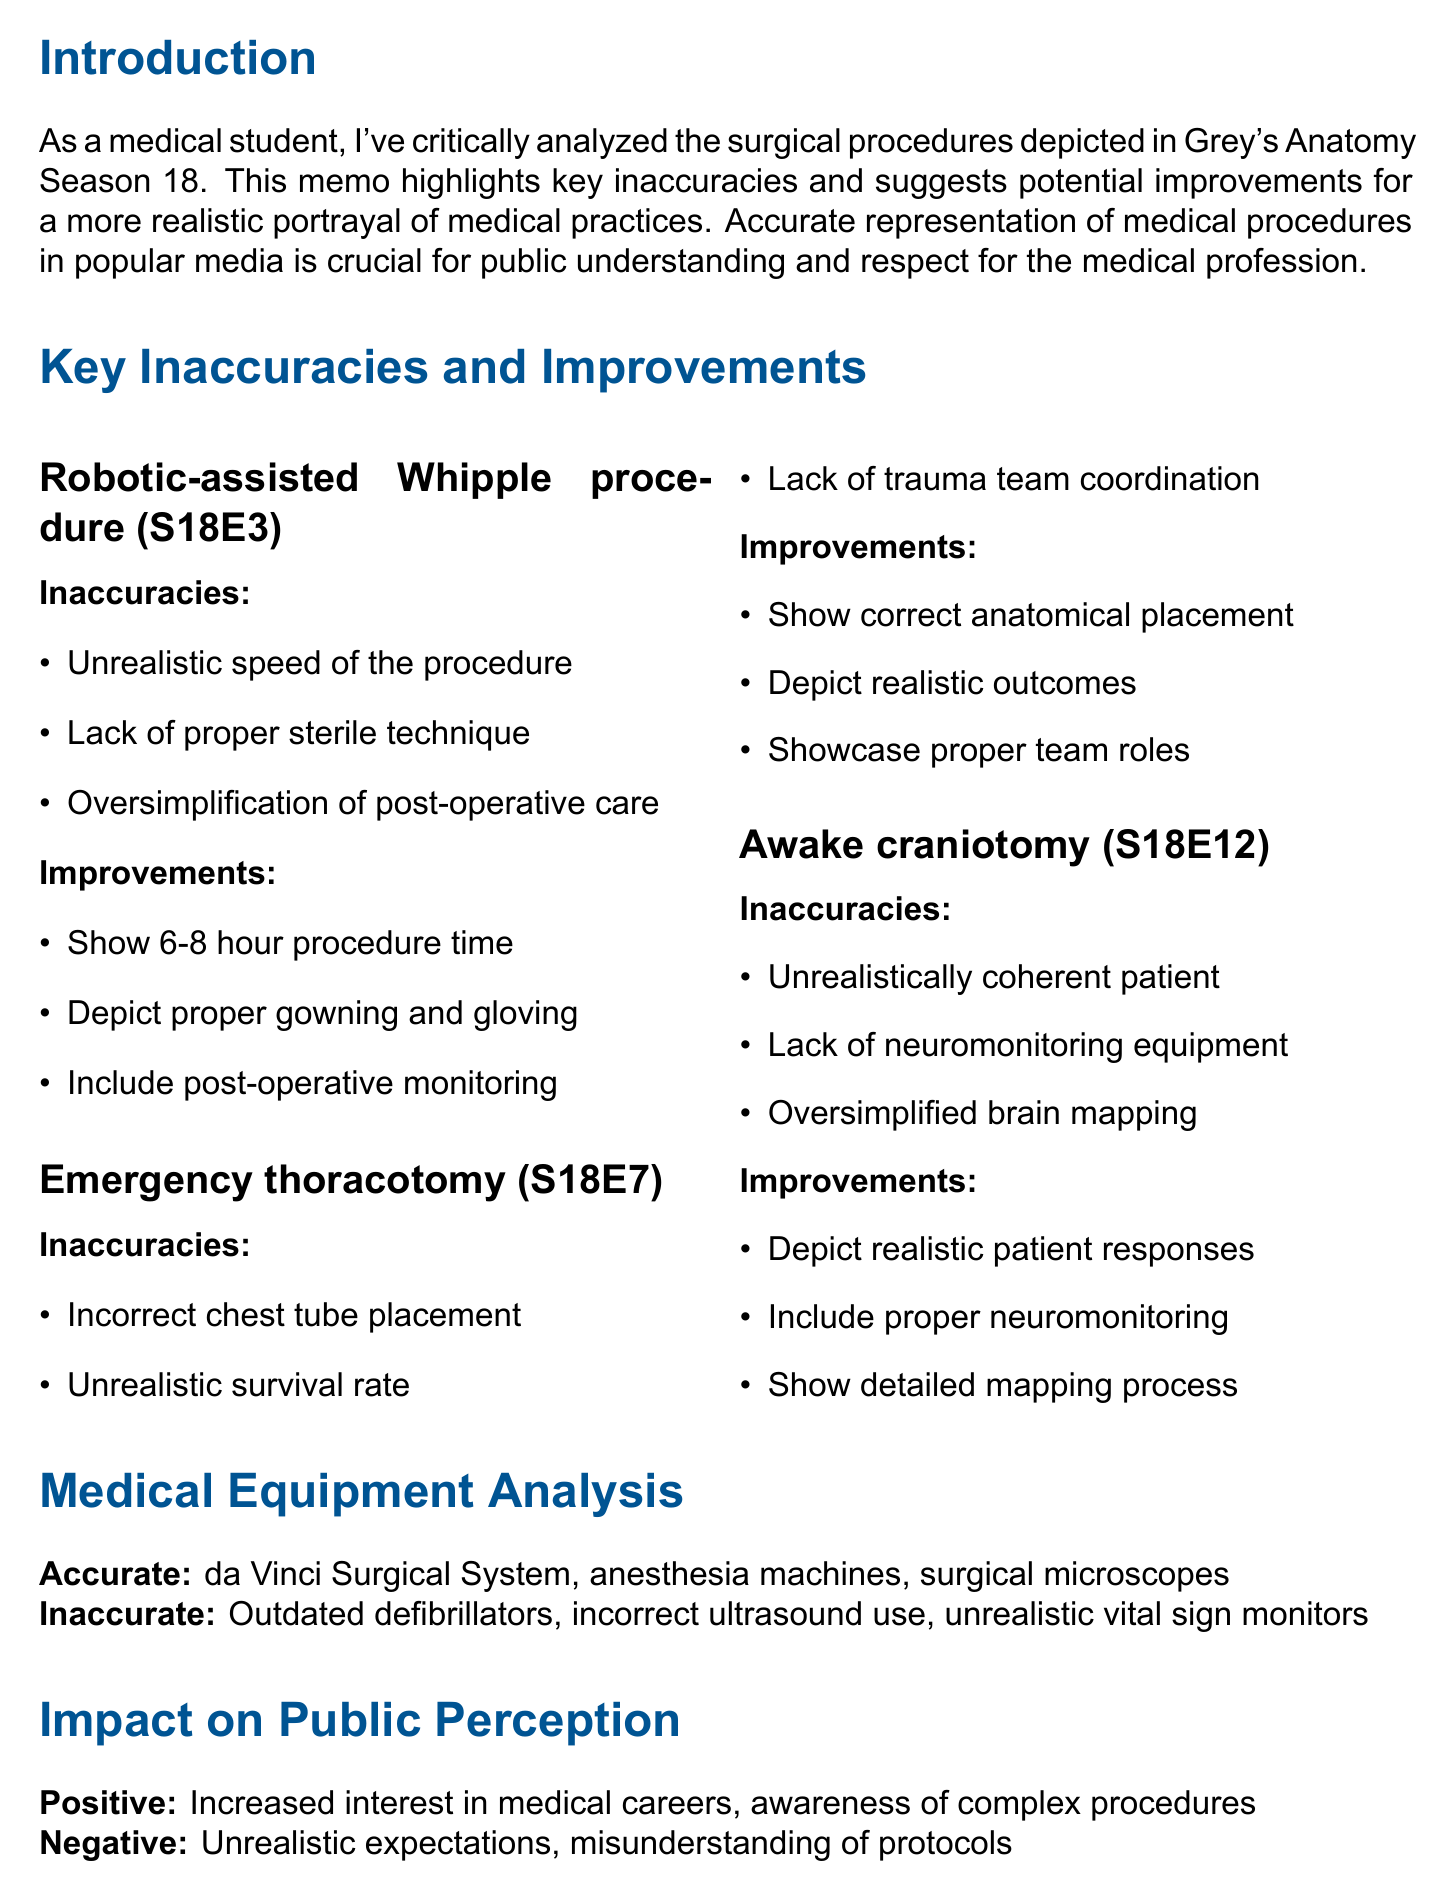what is the title of the memo? The title of the memo is explicitly stated at the beginning of the document, which is "Analysis of Surgical Procedures in Grey's Anatomy Season 18: A Medical Student's Perspective."
Answer: Analysis of Surgical Procedures in Grey's Anatomy Season 18: A Medical Student's Perspective which surgical procedure is analyzed in Season 18, Episode 3? The memo specifies the robotic-assisted Whipple procedure being analyzed in this episode.
Answer: Robotic-assisted Whipple procedure what is one of the positive impacts of Grey's Anatomy on public perception? The memo lists several positive impacts, one of which is increased interest in medical careers.
Answer: Increased interest in medical careers how many inaccuracies are listed for the Emergency thoracotomy procedure? The document outlines three specific inaccuracies for the Emergency thoracotomy procedure.
Answer: Three what is one recommendation provided in the memo? The memo includes multiple recommendations, one being to consult with active medical professionals for script review.
Answer: Consult with active medical professionals for script review what equipment is accurately portrayed in the series according to the document? The memo explicitly mentions the accurate portrayal of the da Vinci Surgical System for minimally invasive procedures.
Answer: da Vinci Surgical System why is accurate representation of medical procedures important? The introduction highlights that accurate representation is crucial for public understanding and respect for the medical profession.
Answer: Public understanding and respect for the medical profession which episode features the awake craniotomy procedure? The memo states that the awake craniotomy procedure is featured in Season 18, Episode 12.
Answer: Season 18, Episode 12 